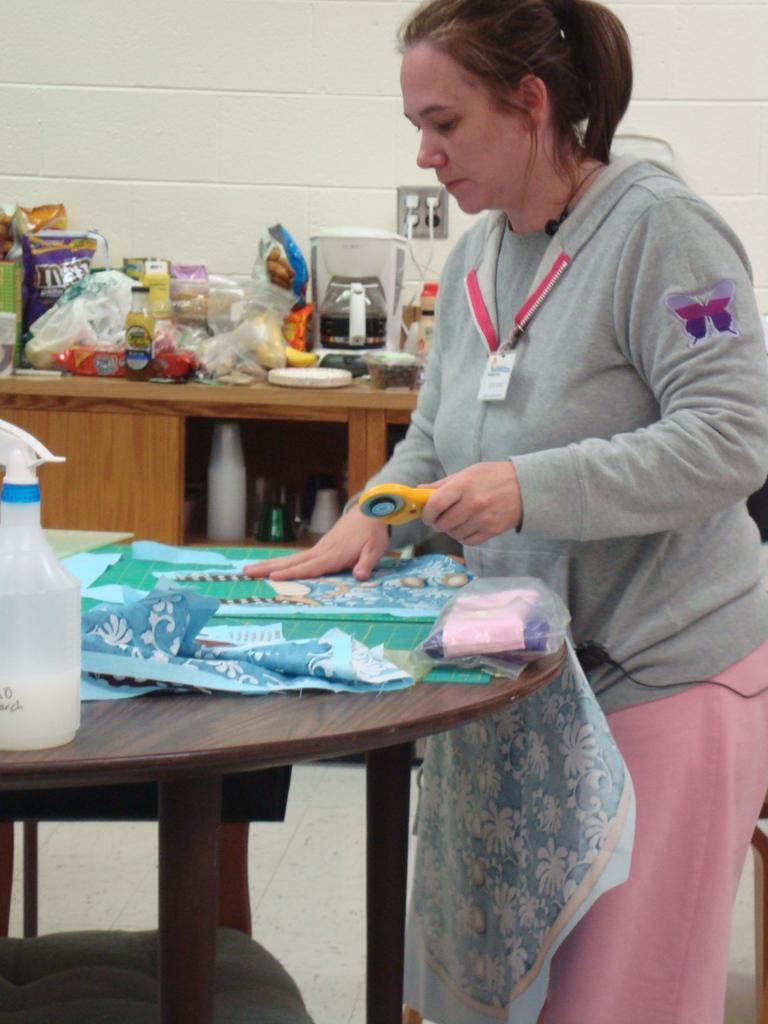Could you give a brief overview of what you see in this image? In this image I can see the person standing in front of the table. There is a cloth on the table. At the right to her there are some objects. 